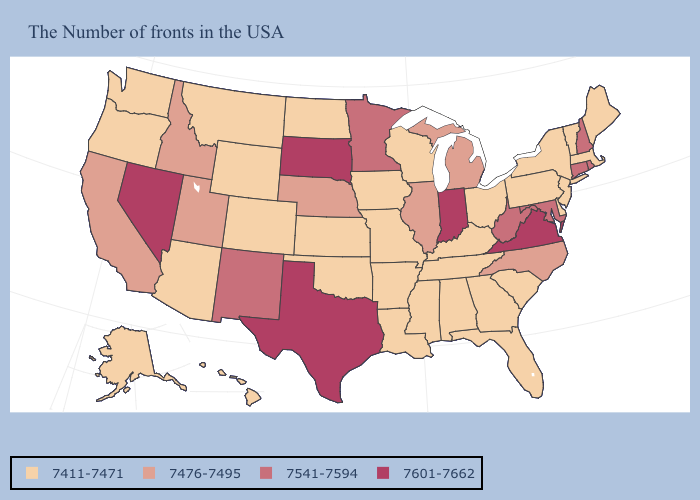Is the legend a continuous bar?
Answer briefly. No. What is the value of South Dakota?
Be succinct. 7601-7662. What is the value of Alabama?
Write a very short answer. 7411-7471. Among the states that border North Carolina , which have the lowest value?
Concise answer only. South Carolina, Georgia, Tennessee. Which states have the lowest value in the MidWest?
Write a very short answer. Ohio, Wisconsin, Missouri, Iowa, Kansas, North Dakota. Name the states that have a value in the range 7411-7471?
Give a very brief answer. Maine, Massachusetts, Vermont, New York, New Jersey, Delaware, Pennsylvania, South Carolina, Ohio, Florida, Georgia, Kentucky, Alabama, Tennessee, Wisconsin, Mississippi, Louisiana, Missouri, Arkansas, Iowa, Kansas, Oklahoma, North Dakota, Wyoming, Colorado, Montana, Arizona, Washington, Oregon, Alaska, Hawaii. Among the states that border Kansas , which have the highest value?
Quick response, please. Nebraska. What is the value of Tennessee?
Short answer required. 7411-7471. Which states have the highest value in the USA?
Answer briefly. Virginia, Indiana, Texas, South Dakota, Nevada. What is the highest value in the West ?
Short answer required. 7601-7662. What is the value of Virginia?
Write a very short answer. 7601-7662. Does South Carolina have the lowest value in the South?
Keep it brief. Yes. Which states have the lowest value in the USA?
Answer briefly. Maine, Massachusetts, Vermont, New York, New Jersey, Delaware, Pennsylvania, South Carolina, Ohio, Florida, Georgia, Kentucky, Alabama, Tennessee, Wisconsin, Mississippi, Louisiana, Missouri, Arkansas, Iowa, Kansas, Oklahoma, North Dakota, Wyoming, Colorado, Montana, Arizona, Washington, Oregon, Alaska, Hawaii. What is the highest value in the USA?
Short answer required. 7601-7662. What is the value of South Dakota?
Answer briefly. 7601-7662. 